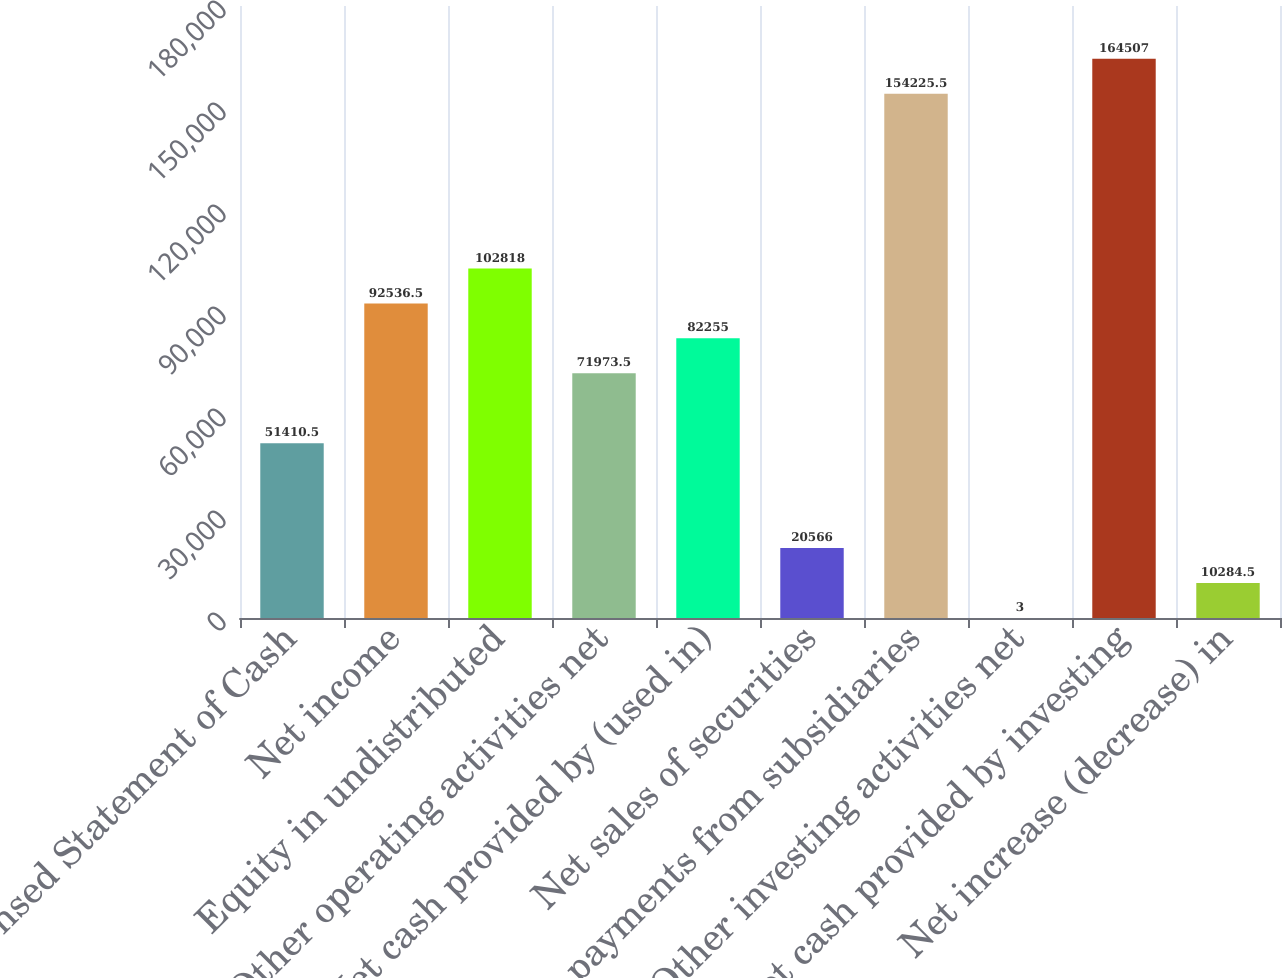Convert chart. <chart><loc_0><loc_0><loc_500><loc_500><bar_chart><fcel>Condensed Statement of Cash<fcel>Net income<fcel>Equity in undistributed<fcel>Other operating activities net<fcel>Net cash provided by (used in)<fcel>Net sales of securities<fcel>Net payments from subsidiaries<fcel>Other investing activities net<fcel>Net cash provided by investing<fcel>Net increase (decrease) in<nl><fcel>51410.5<fcel>92536.5<fcel>102818<fcel>71973.5<fcel>82255<fcel>20566<fcel>154226<fcel>3<fcel>164507<fcel>10284.5<nl></chart> 